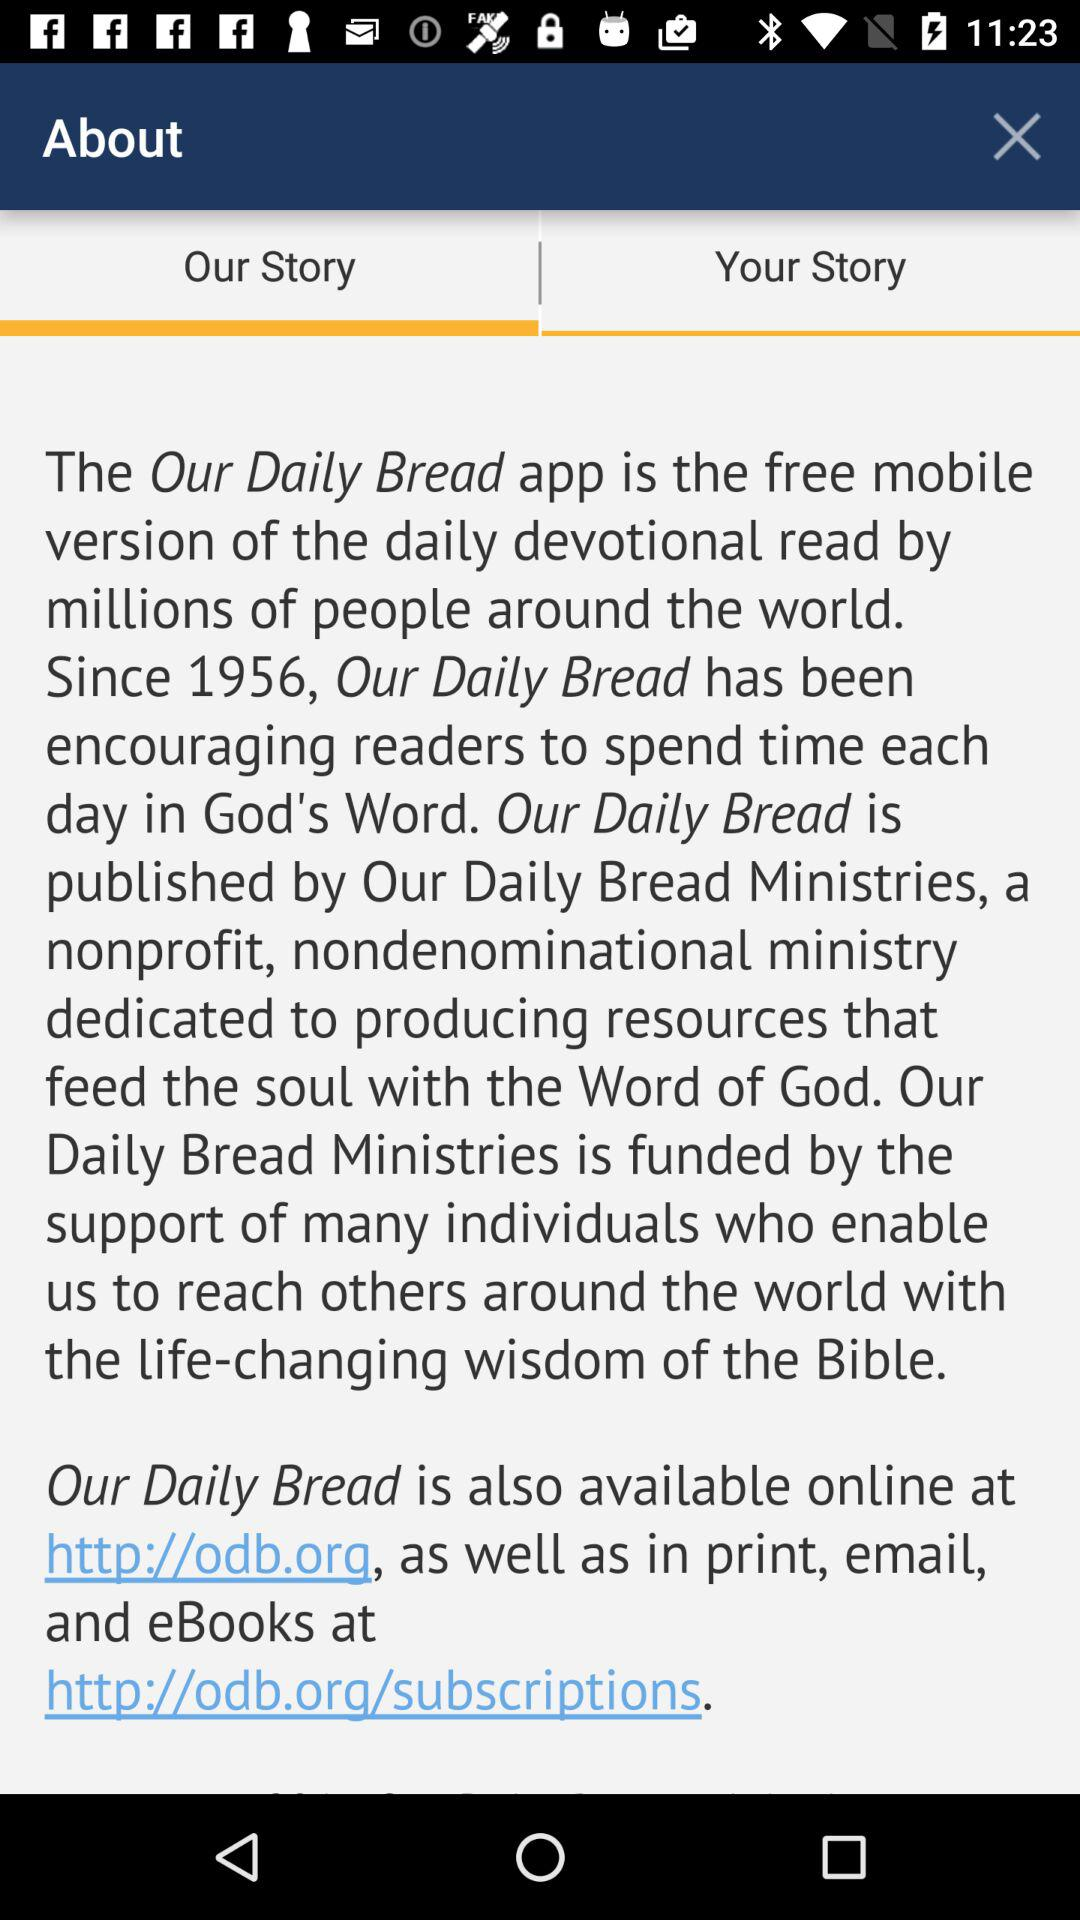How can I contact "Our Daily Bread" by email?
When the provided information is insufficient, respond with <no answer>. <no answer> 